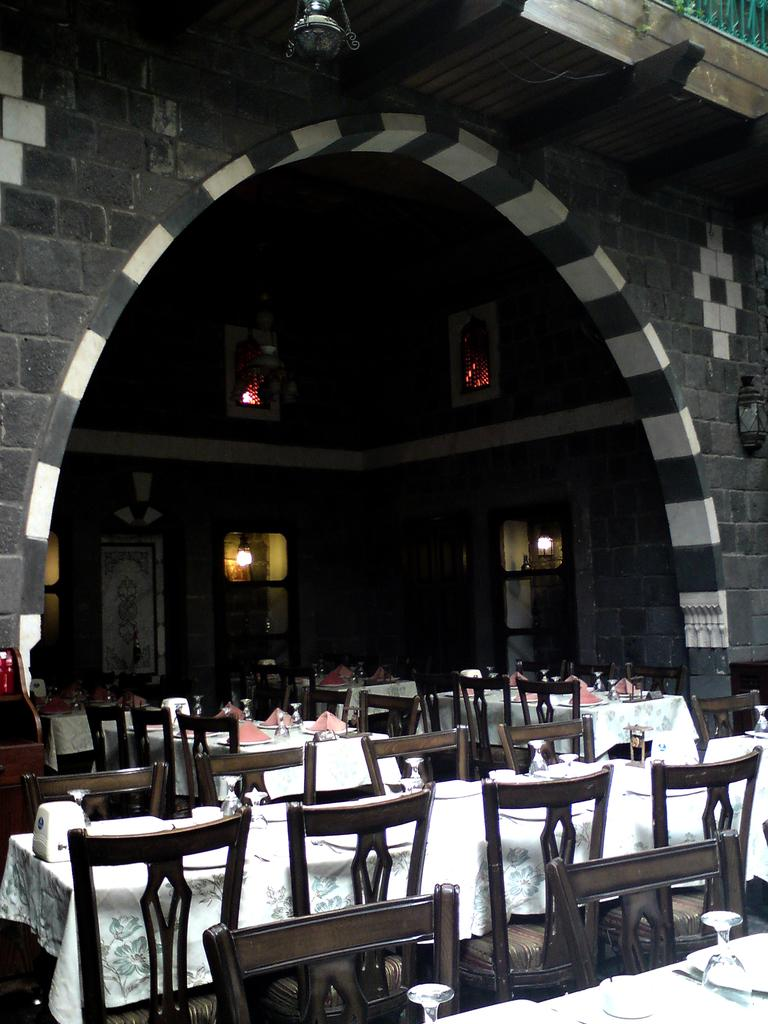What type of furniture is present in the image? There are tables and chairs in the image. What can be seen in the background of the image? There is a wall in the background of the image. Are there any openings in the wall? Yes, there are doors in the wall. What type of cloth is draped over the chairs in the image? There is no cloth draped over the chairs in the image. Is there a hat-wearing beginner in the image? There is no person, let alone a beginner wearing a hat, present in the image. 